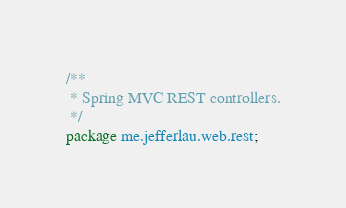<code> <loc_0><loc_0><loc_500><loc_500><_Java_>/**
 * Spring MVC REST controllers.
 */
package me.jefferlau.web.rest;
</code> 